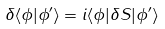<formula> <loc_0><loc_0><loc_500><loc_500>\delta \langle \phi | \phi ^ { \prime } \rangle = i \langle \phi | \delta S | \phi ^ { \prime } \rangle</formula> 